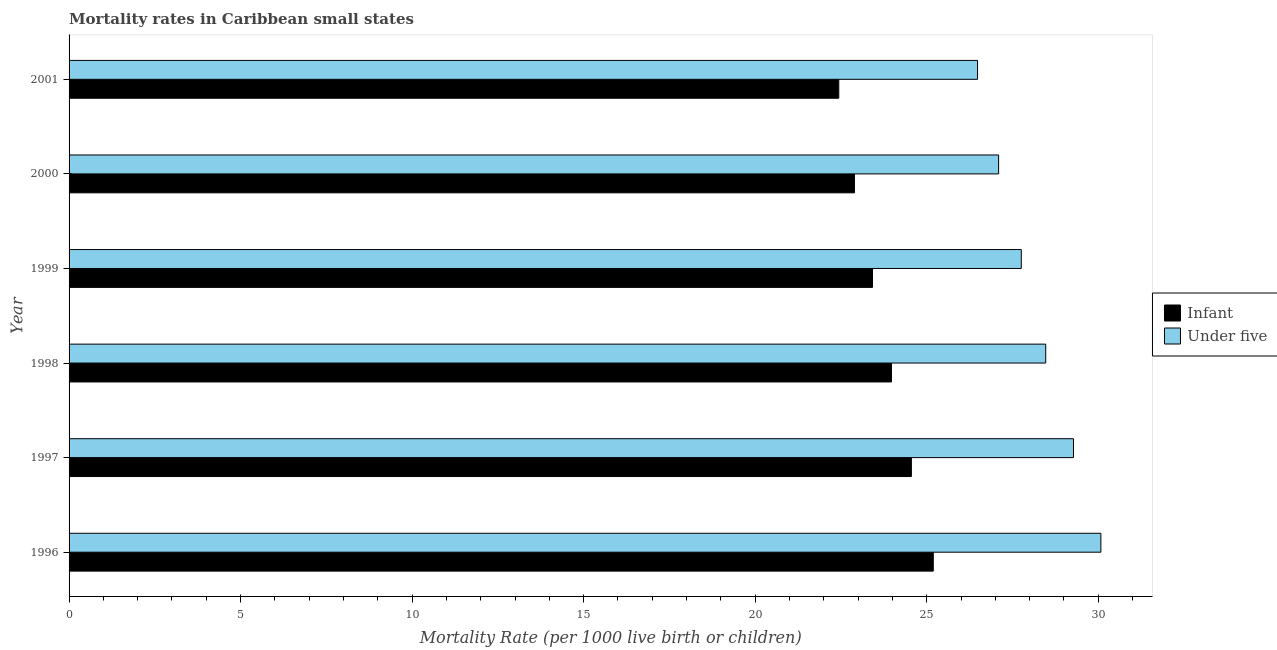How many groups of bars are there?
Ensure brevity in your answer.  6. Are the number of bars per tick equal to the number of legend labels?
Provide a succinct answer. Yes. Are the number of bars on each tick of the Y-axis equal?
Provide a short and direct response. Yes. How many bars are there on the 4th tick from the top?
Provide a short and direct response. 2. What is the label of the 5th group of bars from the top?
Offer a terse response. 1997. In how many cases, is the number of bars for a given year not equal to the number of legend labels?
Offer a terse response. 0. What is the infant mortality rate in 1996?
Keep it short and to the point. 25.19. Across all years, what is the maximum infant mortality rate?
Your answer should be compact. 25.19. Across all years, what is the minimum infant mortality rate?
Make the answer very short. 22.44. In which year was the infant mortality rate maximum?
Keep it short and to the point. 1996. In which year was the under-5 mortality rate minimum?
Provide a succinct answer. 2001. What is the total infant mortality rate in the graph?
Your response must be concise. 142.47. What is the difference between the under-5 mortality rate in 1996 and that in 1998?
Make the answer very short. 1.61. What is the difference between the under-5 mortality rate in 2001 and the infant mortality rate in 2000?
Your answer should be very brief. 3.59. What is the average under-5 mortality rate per year?
Ensure brevity in your answer.  28.19. In the year 2000, what is the difference between the under-5 mortality rate and infant mortality rate?
Provide a succinct answer. 4.2. What is the ratio of the under-5 mortality rate in 2000 to that in 2001?
Offer a very short reply. 1.02. Is the difference between the under-5 mortality rate in 1996 and 1997 greater than the difference between the infant mortality rate in 1996 and 1997?
Your answer should be compact. Yes. What is the difference between the highest and the second highest under-5 mortality rate?
Your answer should be very brief. 0.8. What is the difference between the highest and the lowest under-5 mortality rate?
Your answer should be very brief. 3.59. In how many years, is the under-5 mortality rate greater than the average under-5 mortality rate taken over all years?
Ensure brevity in your answer.  3. Is the sum of the under-5 mortality rate in 1996 and 2001 greater than the maximum infant mortality rate across all years?
Provide a succinct answer. Yes. What does the 2nd bar from the top in 1997 represents?
Make the answer very short. Infant. What does the 2nd bar from the bottom in 2001 represents?
Provide a short and direct response. Under five. What is the difference between two consecutive major ticks on the X-axis?
Your answer should be compact. 5. Does the graph contain grids?
Your answer should be very brief. No. How many legend labels are there?
Make the answer very short. 2. What is the title of the graph?
Your response must be concise. Mortality rates in Caribbean small states. Does "From World Bank" appear as one of the legend labels in the graph?
Your response must be concise. No. What is the label or title of the X-axis?
Provide a succinct answer. Mortality Rate (per 1000 live birth or children). What is the label or title of the Y-axis?
Provide a short and direct response. Year. What is the Mortality Rate (per 1000 live birth or children) of Infant in 1996?
Your answer should be compact. 25.19. What is the Mortality Rate (per 1000 live birth or children) of Under five in 1996?
Your answer should be very brief. 30.08. What is the Mortality Rate (per 1000 live birth or children) in Infant in 1997?
Offer a very short reply. 24.55. What is the Mortality Rate (per 1000 live birth or children) of Under five in 1997?
Make the answer very short. 29.28. What is the Mortality Rate (per 1000 live birth or children) in Infant in 1998?
Your response must be concise. 23.97. What is the Mortality Rate (per 1000 live birth or children) of Under five in 1998?
Ensure brevity in your answer.  28.47. What is the Mortality Rate (per 1000 live birth or children) in Infant in 1999?
Provide a succinct answer. 23.42. What is the Mortality Rate (per 1000 live birth or children) in Under five in 1999?
Give a very brief answer. 27.76. What is the Mortality Rate (per 1000 live birth or children) in Infant in 2000?
Your response must be concise. 22.89. What is the Mortality Rate (per 1000 live birth or children) in Under five in 2000?
Your answer should be compact. 27.1. What is the Mortality Rate (per 1000 live birth or children) of Infant in 2001?
Offer a very short reply. 22.44. What is the Mortality Rate (per 1000 live birth or children) in Under five in 2001?
Offer a very short reply. 26.48. Across all years, what is the maximum Mortality Rate (per 1000 live birth or children) of Infant?
Provide a short and direct response. 25.19. Across all years, what is the maximum Mortality Rate (per 1000 live birth or children) in Under five?
Make the answer very short. 30.08. Across all years, what is the minimum Mortality Rate (per 1000 live birth or children) in Infant?
Your response must be concise. 22.44. Across all years, what is the minimum Mortality Rate (per 1000 live birth or children) of Under five?
Make the answer very short. 26.48. What is the total Mortality Rate (per 1000 live birth or children) of Infant in the graph?
Offer a terse response. 142.47. What is the total Mortality Rate (per 1000 live birth or children) of Under five in the graph?
Offer a very short reply. 169.15. What is the difference between the Mortality Rate (per 1000 live birth or children) of Infant in 1996 and that in 1997?
Your answer should be very brief. 0.64. What is the difference between the Mortality Rate (per 1000 live birth or children) in Under five in 1996 and that in 1997?
Make the answer very short. 0.8. What is the difference between the Mortality Rate (per 1000 live birth or children) in Infant in 1996 and that in 1998?
Offer a terse response. 1.22. What is the difference between the Mortality Rate (per 1000 live birth or children) of Under five in 1996 and that in 1998?
Your answer should be very brief. 1.61. What is the difference between the Mortality Rate (per 1000 live birth or children) of Infant in 1996 and that in 1999?
Keep it short and to the point. 1.77. What is the difference between the Mortality Rate (per 1000 live birth or children) in Under five in 1996 and that in 1999?
Your answer should be very brief. 2.32. What is the difference between the Mortality Rate (per 1000 live birth or children) of Infant in 1996 and that in 2000?
Give a very brief answer. 2.3. What is the difference between the Mortality Rate (per 1000 live birth or children) of Under five in 1996 and that in 2000?
Offer a terse response. 2.98. What is the difference between the Mortality Rate (per 1000 live birth or children) of Infant in 1996 and that in 2001?
Your answer should be compact. 2.75. What is the difference between the Mortality Rate (per 1000 live birth or children) of Under five in 1996 and that in 2001?
Offer a very short reply. 3.59. What is the difference between the Mortality Rate (per 1000 live birth or children) in Infant in 1997 and that in 1998?
Make the answer very short. 0.58. What is the difference between the Mortality Rate (per 1000 live birth or children) in Under five in 1997 and that in 1998?
Offer a very short reply. 0.81. What is the difference between the Mortality Rate (per 1000 live birth or children) of Infant in 1997 and that in 1999?
Provide a short and direct response. 1.13. What is the difference between the Mortality Rate (per 1000 live birth or children) in Under five in 1997 and that in 1999?
Offer a very short reply. 1.52. What is the difference between the Mortality Rate (per 1000 live birth or children) of Infant in 1997 and that in 2000?
Provide a short and direct response. 1.66. What is the difference between the Mortality Rate (per 1000 live birth or children) in Under five in 1997 and that in 2000?
Make the answer very short. 2.18. What is the difference between the Mortality Rate (per 1000 live birth or children) of Infant in 1997 and that in 2001?
Provide a succinct answer. 2.12. What is the difference between the Mortality Rate (per 1000 live birth or children) in Under five in 1997 and that in 2001?
Ensure brevity in your answer.  2.8. What is the difference between the Mortality Rate (per 1000 live birth or children) in Infant in 1998 and that in 1999?
Offer a very short reply. 0.55. What is the difference between the Mortality Rate (per 1000 live birth or children) in Under five in 1998 and that in 1999?
Keep it short and to the point. 0.71. What is the difference between the Mortality Rate (per 1000 live birth or children) in Infant in 1998 and that in 2000?
Ensure brevity in your answer.  1.08. What is the difference between the Mortality Rate (per 1000 live birth or children) in Under five in 1998 and that in 2000?
Offer a terse response. 1.37. What is the difference between the Mortality Rate (per 1000 live birth or children) of Infant in 1998 and that in 2001?
Your answer should be compact. 1.54. What is the difference between the Mortality Rate (per 1000 live birth or children) of Under five in 1998 and that in 2001?
Make the answer very short. 1.99. What is the difference between the Mortality Rate (per 1000 live birth or children) in Infant in 1999 and that in 2000?
Your answer should be compact. 0.53. What is the difference between the Mortality Rate (per 1000 live birth or children) of Under five in 1999 and that in 2000?
Ensure brevity in your answer.  0.66. What is the difference between the Mortality Rate (per 1000 live birth or children) of Infant in 1999 and that in 2001?
Make the answer very short. 0.98. What is the difference between the Mortality Rate (per 1000 live birth or children) in Under five in 1999 and that in 2001?
Provide a short and direct response. 1.27. What is the difference between the Mortality Rate (per 1000 live birth or children) in Infant in 2000 and that in 2001?
Make the answer very short. 0.46. What is the difference between the Mortality Rate (per 1000 live birth or children) in Under five in 2000 and that in 2001?
Ensure brevity in your answer.  0.61. What is the difference between the Mortality Rate (per 1000 live birth or children) of Infant in 1996 and the Mortality Rate (per 1000 live birth or children) of Under five in 1997?
Give a very brief answer. -4.09. What is the difference between the Mortality Rate (per 1000 live birth or children) of Infant in 1996 and the Mortality Rate (per 1000 live birth or children) of Under five in 1998?
Offer a very short reply. -3.28. What is the difference between the Mortality Rate (per 1000 live birth or children) of Infant in 1996 and the Mortality Rate (per 1000 live birth or children) of Under five in 1999?
Provide a short and direct response. -2.56. What is the difference between the Mortality Rate (per 1000 live birth or children) of Infant in 1996 and the Mortality Rate (per 1000 live birth or children) of Under five in 2000?
Ensure brevity in your answer.  -1.9. What is the difference between the Mortality Rate (per 1000 live birth or children) in Infant in 1996 and the Mortality Rate (per 1000 live birth or children) in Under five in 2001?
Your answer should be very brief. -1.29. What is the difference between the Mortality Rate (per 1000 live birth or children) in Infant in 1997 and the Mortality Rate (per 1000 live birth or children) in Under five in 1998?
Make the answer very short. -3.92. What is the difference between the Mortality Rate (per 1000 live birth or children) in Infant in 1997 and the Mortality Rate (per 1000 live birth or children) in Under five in 1999?
Give a very brief answer. -3.2. What is the difference between the Mortality Rate (per 1000 live birth or children) of Infant in 1997 and the Mortality Rate (per 1000 live birth or children) of Under five in 2000?
Make the answer very short. -2.54. What is the difference between the Mortality Rate (per 1000 live birth or children) of Infant in 1997 and the Mortality Rate (per 1000 live birth or children) of Under five in 2001?
Give a very brief answer. -1.93. What is the difference between the Mortality Rate (per 1000 live birth or children) of Infant in 1998 and the Mortality Rate (per 1000 live birth or children) of Under five in 1999?
Provide a short and direct response. -3.78. What is the difference between the Mortality Rate (per 1000 live birth or children) of Infant in 1998 and the Mortality Rate (per 1000 live birth or children) of Under five in 2000?
Your response must be concise. -3.12. What is the difference between the Mortality Rate (per 1000 live birth or children) in Infant in 1998 and the Mortality Rate (per 1000 live birth or children) in Under five in 2001?
Give a very brief answer. -2.51. What is the difference between the Mortality Rate (per 1000 live birth or children) of Infant in 1999 and the Mortality Rate (per 1000 live birth or children) of Under five in 2000?
Your response must be concise. -3.68. What is the difference between the Mortality Rate (per 1000 live birth or children) in Infant in 1999 and the Mortality Rate (per 1000 live birth or children) in Under five in 2001?
Your response must be concise. -3.06. What is the difference between the Mortality Rate (per 1000 live birth or children) in Infant in 2000 and the Mortality Rate (per 1000 live birth or children) in Under five in 2001?
Your response must be concise. -3.59. What is the average Mortality Rate (per 1000 live birth or children) in Infant per year?
Provide a succinct answer. 23.74. What is the average Mortality Rate (per 1000 live birth or children) in Under five per year?
Ensure brevity in your answer.  28.19. In the year 1996, what is the difference between the Mortality Rate (per 1000 live birth or children) in Infant and Mortality Rate (per 1000 live birth or children) in Under five?
Provide a short and direct response. -4.88. In the year 1997, what is the difference between the Mortality Rate (per 1000 live birth or children) in Infant and Mortality Rate (per 1000 live birth or children) in Under five?
Keep it short and to the point. -4.73. In the year 1998, what is the difference between the Mortality Rate (per 1000 live birth or children) in Infant and Mortality Rate (per 1000 live birth or children) in Under five?
Your answer should be compact. -4.5. In the year 1999, what is the difference between the Mortality Rate (per 1000 live birth or children) of Infant and Mortality Rate (per 1000 live birth or children) of Under five?
Your answer should be compact. -4.34. In the year 2000, what is the difference between the Mortality Rate (per 1000 live birth or children) of Infant and Mortality Rate (per 1000 live birth or children) of Under five?
Make the answer very short. -4.2. In the year 2001, what is the difference between the Mortality Rate (per 1000 live birth or children) in Infant and Mortality Rate (per 1000 live birth or children) in Under five?
Make the answer very short. -4.05. What is the ratio of the Mortality Rate (per 1000 live birth or children) of Under five in 1996 to that in 1997?
Your response must be concise. 1.03. What is the ratio of the Mortality Rate (per 1000 live birth or children) of Infant in 1996 to that in 1998?
Offer a terse response. 1.05. What is the ratio of the Mortality Rate (per 1000 live birth or children) in Under five in 1996 to that in 1998?
Your answer should be very brief. 1.06. What is the ratio of the Mortality Rate (per 1000 live birth or children) of Infant in 1996 to that in 1999?
Offer a terse response. 1.08. What is the ratio of the Mortality Rate (per 1000 live birth or children) in Under five in 1996 to that in 1999?
Provide a short and direct response. 1.08. What is the ratio of the Mortality Rate (per 1000 live birth or children) in Infant in 1996 to that in 2000?
Provide a short and direct response. 1.1. What is the ratio of the Mortality Rate (per 1000 live birth or children) in Under five in 1996 to that in 2000?
Your answer should be very brief. 1.11. What is the ratio of the Mortality Rate (per 1000 live birth or children) of Infant in 1996 to that in 2001?
Give a very brief answer. 1.12. What is the ratio of the Mortality Rate (per 1000 live birth or children) of Under five in 1996 to that in 2001?
Provide a short and direct response. 1.14. What is the ratio of the Mortality Rate (per 1000 live birth or children) of Infant in 1997 to that in 1998?
Give a very brief answer. 1.02. What is the ratio of the Mortality Rate (per 1000 live birth or children) in Under five in 1997 to that in 1998?
Offer a terse response. 1.03. What is the ratio of the Mortality Rate (per 1000 live birth or children) in Infant in 1997 to that in 1999?
Your answer should be very brief. 1.05. What is the ratio of the Mortality Rate (per 1000 live birth or children) of Under five in 1997 to that in 1999?
Your answer should be very brief. 1.05. What is the ratio of the Mortality Rate (per 1000 live birth or children) in Infant in 1997 to that in 2000?
Provide a short and direct response. 1.07. What is the ratio of the Mortality Rate (per 1000 live birth or children) of Under five in 1997 to that in 2000?
Your response must be concise. 1.08. What is the ratio of the Mortality Rate (per 1000 live birth or children) in Infant in 1997 to that in 2001?
Provide a short and direct response. 1.09. What is the ratio of the Mortality Rate (per 1000 live birth or children) in Under five in 1997 to that in 2001?
Offer a very short reply. 1.11. What is the ratio of the Mortality Rate (per 1000 live birth or children) in Infant in 1998 to that in 1999?
Your response must be concise. 1.02. What is the ratio of the Mortality Rate (per 1000 live birth or children) in Under five in 1998 to that in 1999?
Your response must be concise. 1.03. What is the ratio of the Mortality Rate (per 1000 live birth or children) of Infant in 1998 to that in 2000?
Make the answer very short. 1.05. What is the ratio of the Mortality Rate (per 1000 live birth or children) in Under five in 1998 to that in 2000?
Your answer should be compact. 1.05. What is the ratio of the Mortality Rate (per 1000 live birth or children) of Infant in 1998 to that in 2001?
Your response must be concise. 1.07. What is the ratio of the Mortality Rate (per 1000 live birth or children) in Under five in 1998 to that in 2001?
Offer a very short reply. 1.07. What is the ratio of the Mortality Rate (per 1000 live birth or children) of Infant in 1999 to that in 2000?
Ensure brevity in your answer.  1.02. What is the ratio of the Mortality Rate (per 1000 live birth or children) in Under five in 1999 to that in 2000?
Offer a terse response. 1.02. What is the ratio of the Mortality Rate (per 1000 live birth or children) of Infant in 1999 to that in 2001?
Offer a terse response. 1.04. What is the ratio of the Mortality Rate (per 1000 live birth or children) in Under five in 1999 to that in 2001?
Make the answer very short. 1.05. What is the ratio of the Mortality Rate (per 1000 live birth or children) of Infant in 2000 to that in 2001?
Your answer should be very brief. 1.02. What is the ratio of the Mortality Rate (per 1000 live birth or children) of Under five in 2000 to that in 2001?
Give a very brief answer. 1.02. What is the difference between the highest and the second highest Mortality Rate (per 1000 live birth or children) in Infant?
Keep it short and to the point. 0.64. What is the difference between the highest and the second highest Mortality Rate (per 1000 live birth or children) in Under five?
Offer a very short reply. 0.8. What is the difference between the highest and the lowest Mortality Rate (per 1000 live birth or children) in Infant?
Keep it short and to the point. 2.75. What is the difference between the highest and the lowest Mortality Rate (per 1000 live birth or children) of Under five?
Give a very brief answer. 3.59. 